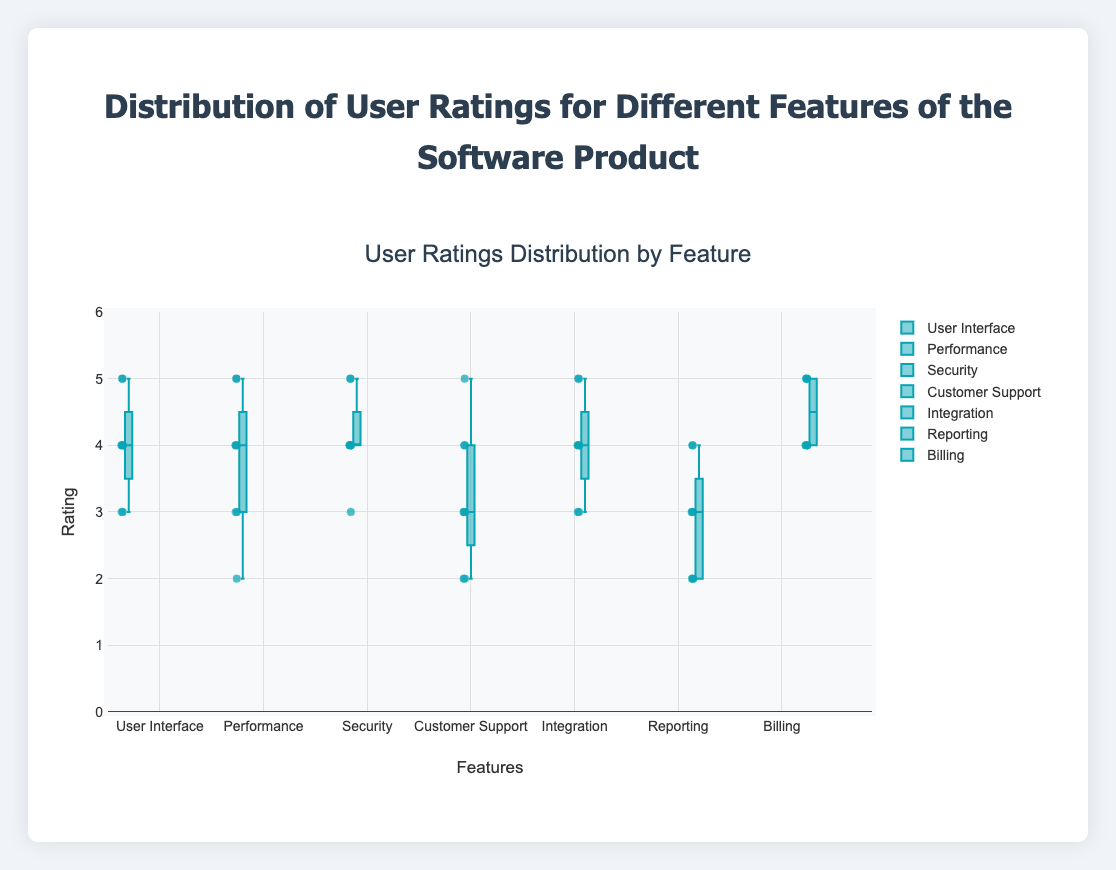what is the title of the figure? The title is found at the top of the figure and provides a clear description of what the figure is about.
Answer: Distribution of User Ratings for Different Features of the Software Product which feature has the highest median rating? To determine the feature with the highest median rating, look for the middle line in each box plot. The feature with the highest median line is the one with the highest median rating.
Answer: Billing how many features have a median rating of 4? Check the middle line (median) of each box plot to see how many align with the rating of 4.
Answer: 4 (User Interface, Security, Integration, Billing) what is the range of ratings for Customer Support? Inspect the top and bottom of the box plot for Customer Support. The range extends from the minimum value to the maximum value.
Answer: 2 to 5 which feature shows the widest spread in ratings? Find the feature whose box plot spans the greatest range between its minimum and maximum values. This indicates the widest spread.
Answer: Customer Support are there any outliers in the ratings for Security? Look for individual points outside the whiskers of the box plot for Security. Outliers are typically shown separately from the box.
Answer: No which feature has the most consistent ratings (smallest interquartile range)? The consistency can be judged by the size of the box in the plot; the smallest box indicates the smallest interquartile range.
Answer: Security what is the most frequent rating for Reporting? Identify the data points plotted; the value that appears most frequently is the mode.
Answer: 3 how does the median rating of Performance compare to that of Integration? Compare the position of the median line in the box plots of Performance and Integration.
Answer: Equal which feature has the lowest lowest individual rating (minimum value)? Check the lower whisker or the lowest point in each box plot. The feature with the lowest point represents the lowest individual rating.
Answer: Performance 